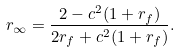Convert formula to latex. <formula><loc_0><loc_0><loc_500><loc_500>r _ { \infty } = \frac { 2 - c ^ { 2 } ( 1 + r _ { f } ) } { 2 r _ { f } + c ^ { 2 } ( 1 + r _ { f } ) } .</formula> 